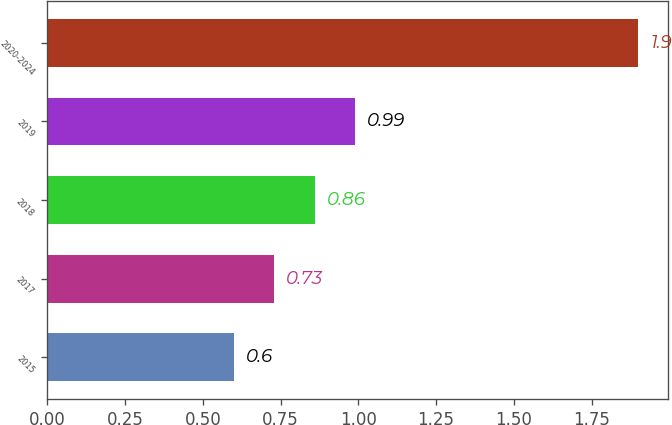Convert chart. <chart><loc_0><loc_0><loc_500><loc_500><bar_chart><fcel>2015<fcel>2017<fcel>2018<fcel>2019<fcel>2020-2024<nl><fcel>0.6<fcel>0.73<fcel>0.86<fcel>0.99<fcel>1.9<nl></chart> 